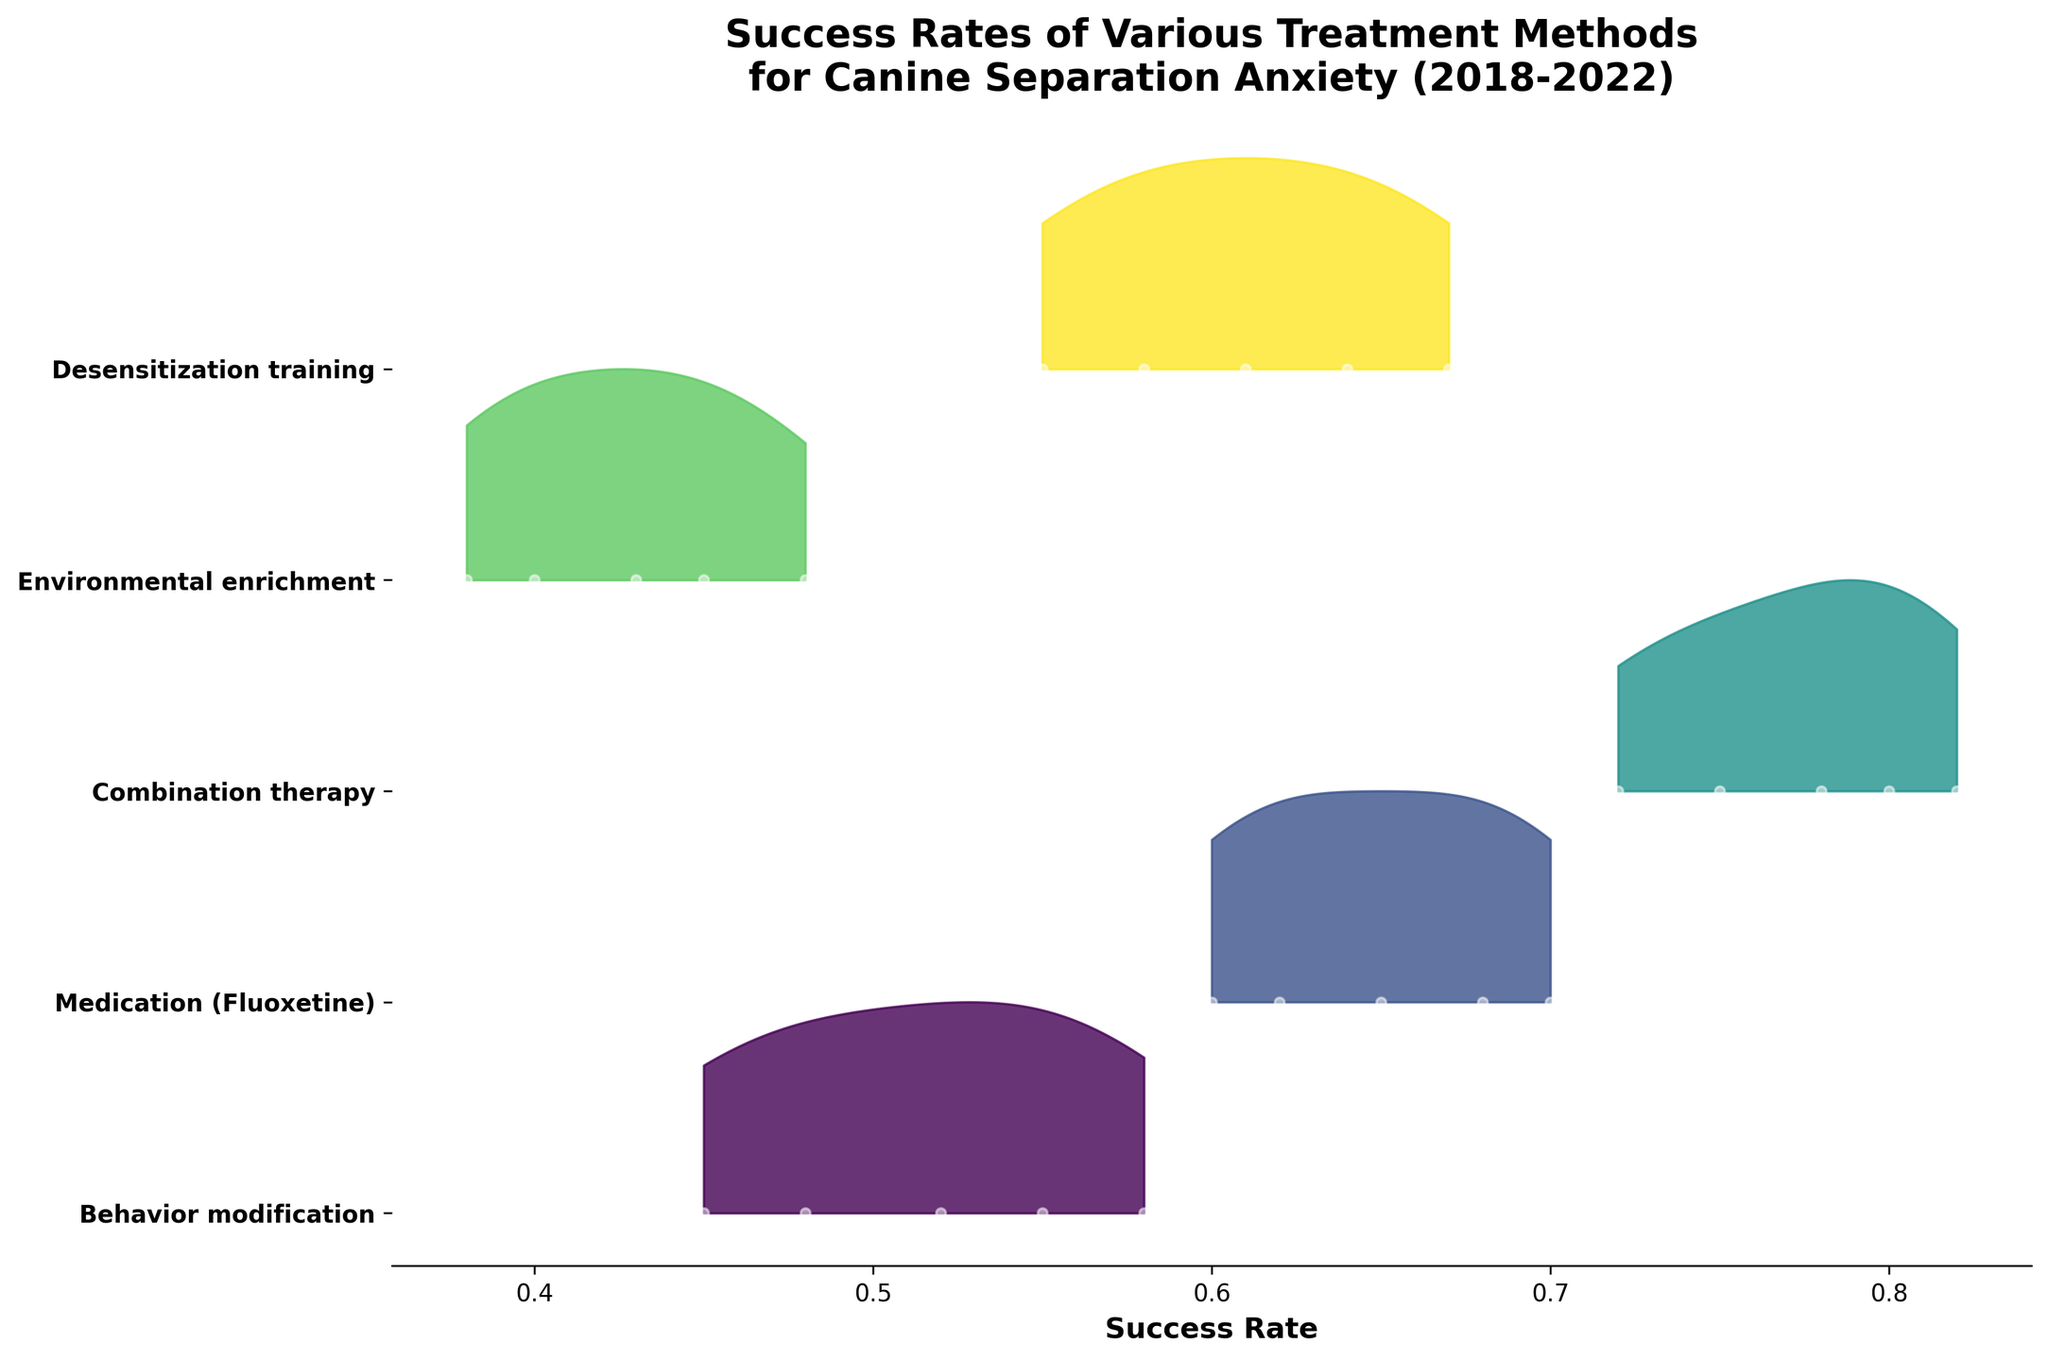What is the title of the plot? The title is usually displayed at the top of the plot. In this figure, the title is clearly stated.
Answer: Success Rates of Various Treatment Methods for Canine Separation Anxiety (2018-2022) How many treatment methods are shown in the plot? To find the number of treatment methods, look at the y-axis labels where each method is listed.
Answer: 5 What is the x-axis label? The x-axis label is located at the bottom of the plot and indicates what the horizontal axis represents.
Answer: Success Rate Which treatment method shows the highest success rate in 2022? Look at the highest position on the x-axis for the year 2022 for each treatment method and compare their values.
Answer: Combination therapy How does the success rate of Behavioral modification in 2018 compare to that in 2020? Look at the success rate data points for Behavioral modification in the years 2018 and 2020, then compare these values.
Answer: The success rate increased from 0.45 in 2018 to 0.52 in 2020 Which treatment method has the least variation in success rates over the years? To determine the least variation, look at the density and spread of the success rates for each treatment method along the y-range for each method. The one with the least spread has the least variation.
Answer: Environmental enrichment How does the success rate for Desensitization training in 2021 compare to Medication (Fluoxetine) in the same year? Examine the data points for both Desensitization training and Medication (Fluoxetine) for the year 2021 and compare their values.
Answer: Desensitization training has a success rate of 0.64, while Medication (Fluoxetine) has a success rate of 0.68 What is the overall trend in success rates for Combination therapy from 2018 to 2022? Look at the progression of success rate data points for Combination therapy from 2018 to 2022 to determine if it is increasing, decreasing, or fluctuating.
Answer: Increasing Is there any treatment method that did not show any increase in success rate from 2018 to 2022? Observe the values for each treatment method across the years 2018 to 2022 and check if they all have an increasing trend.
Answer: No, all methods show an increase in success rate What can you infer about the effectiveness of Environmental enrichment compared to other methods based on the success rates from 2018 to 2022? Compare the success rates of Environmental enrichment with other methods over the years; check if it consistently shows lower or higher values.
Answer: Environmental enrichment is generally less effective compared to other methods 